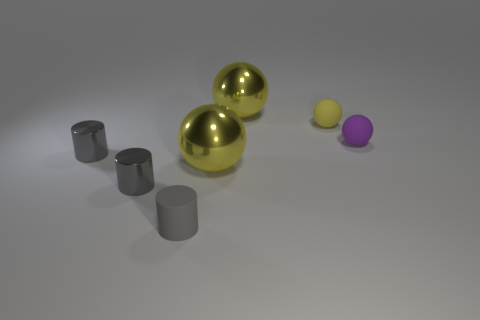Is the color of the shiny sphere that is behind the tiny yellow object the same as the sphere that is in front of the purple sphere?
Offer a very short reply. Yes. Are there an equal number of small gray metallic things that are in front of the tiny purple rubber sphere and tiny rubber balls?
Provide a succinct answer. Yes. Is the small purple sphere made of the same material as the tiny yellow sphere?
Your answer should be compact. Yes. How big is the ball that is both in front of the yellow matte object and to the left of the tiny purple matte thing?
Ensure brevity in your answer.  Large. How many green matte objects have the same size as the purple rubber thing?
Your response must be concise. 0. There is a yellow sphere that is behind the yellow matte object that is left of the tiny purple thing; what size is it?
Provide a succinct answer. Large. There is a large yellow object in front of the purple matte thing; is its shape the same as the big shiny thing that is behind the tiny purple thing?
Keep it short and to the point. Yes. There is a tiny matte object that is both in front of the yellow rubber sphere and on the right side of the small gray rubber cylinder; what is its color?
Make the answer very short. Purple. Are there any metal cylinders that have the same color as the tiny matte cylinder?
Ensure brevity in your answer.  Yes. There is a matte ball that is to the left of the tiny purple rubber object; what is its color?
Your answer should be very brief. Yellow. 